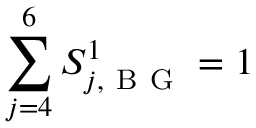<formula> <loc_0><loc_0><loc_500><loc_500>\sum _ { j = 4 } ^ { 6 } S _ { j , B G } ^ { 1 } = 1</formula> 